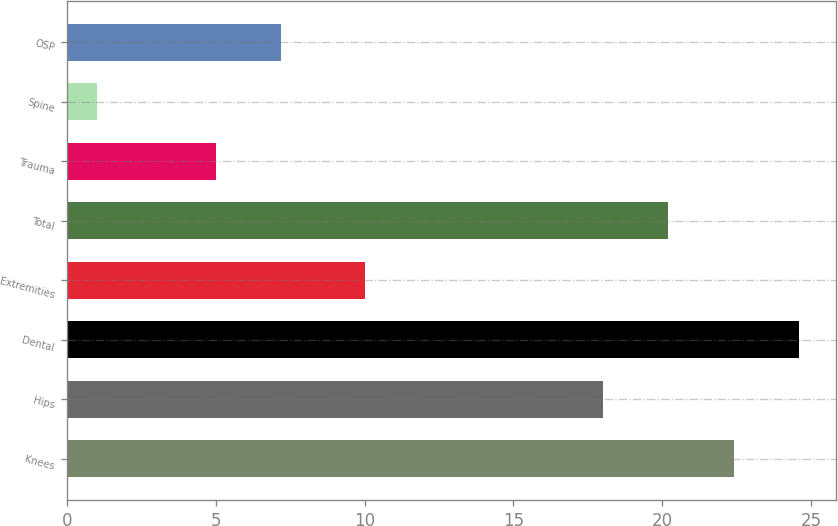<chart> <loc_0><loc_0><loc_500><loc_500><bar_chart><fcel>Knees<fcel>Hips<fcel>Dental<fcel>Extremities<fcel>Total<fcel>Trauma<fcel>Spine<fcel>OSP<nl><fcel>22.4<fcel>18<fcel>24.6<fcel>10<fcel>20.2<fcel>5<fcel>1<fcel>7.2<nl></chart> 